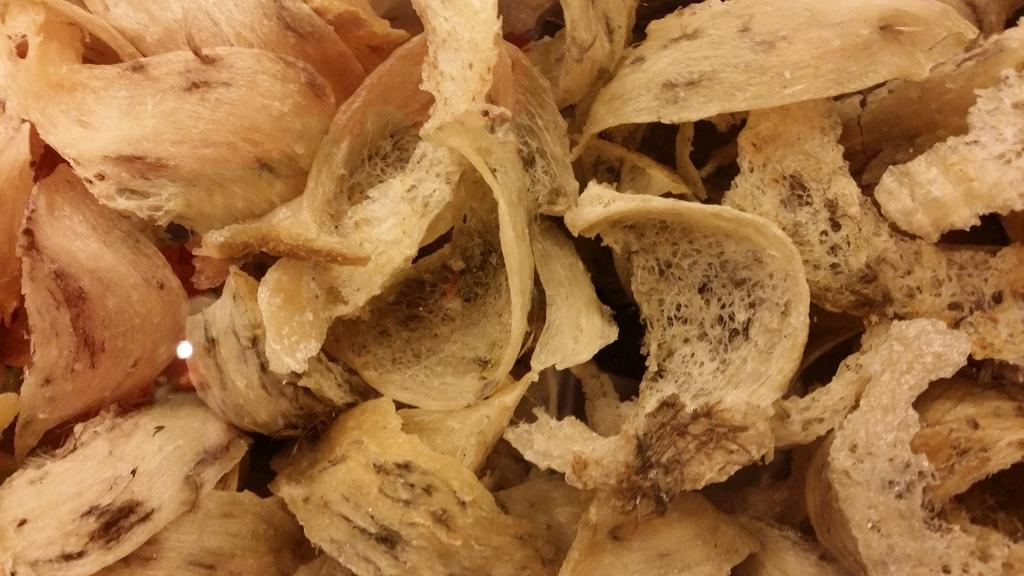What is present in the image related to food? There is food in the image. Can you describe the colors of the food? The food has cream and brown colors. What type of clouds can be seen in the image? There are no clouds present in the image, as it only features food with cream and brown colors. 